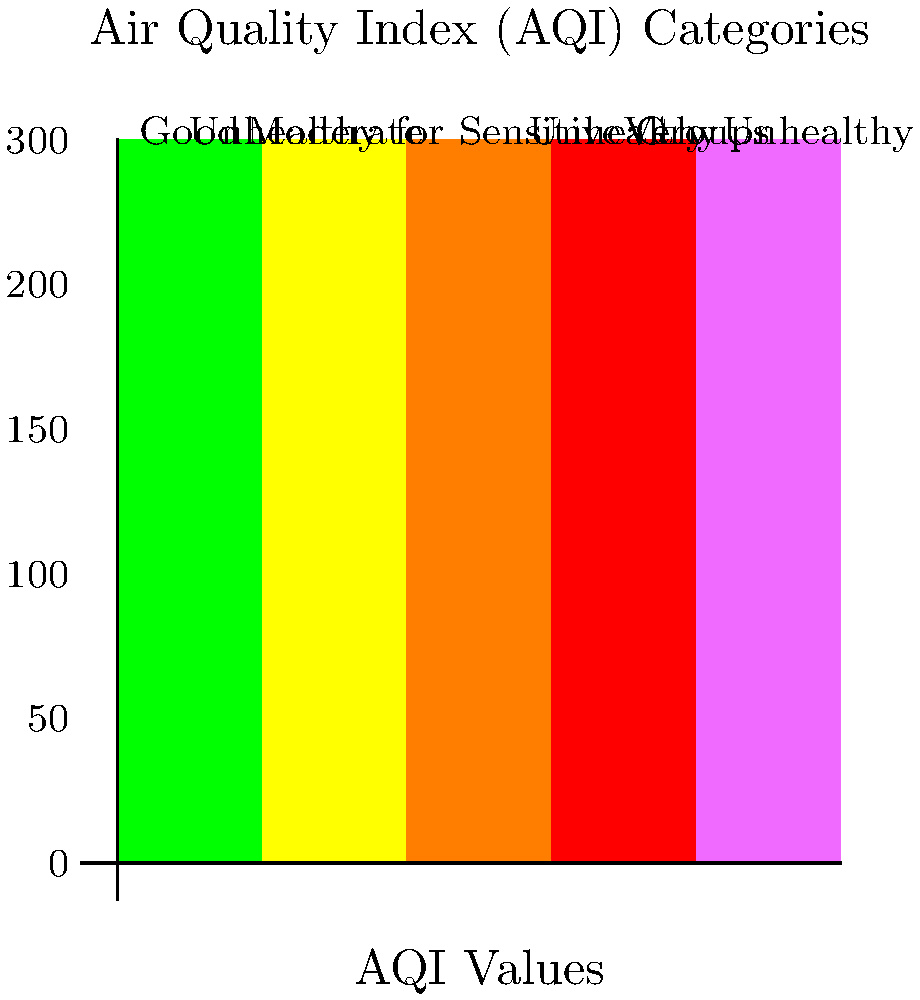Based on the color-coded Air Quality Index (AQI) map provided, what would be the appropriate health advisory for the general public if a city's AQI value is reported as 175? To determine the appropriate health advisory for an AQI value of 175, we need to follow these steps:

1. Locate the AQI value of 175 on the vertical axis of the chart.
2. Identify the corresponding color category for this value.
3. Interpret the meaning of this category in terms of health effects.

Step 1: An AQI value of 175 falls between 150 and 200 on the vertical axis.

Step 2: The color corresponding to this range is red.

Step 3: The red category is labeled "Unhealthy" in the AQI Categories.

Interpretation:
When the AQI is in the "Unhealthy" range (151-200):
- Everyone may begin to experience some adverse health effects.
- Members of sensitive groups (e.g., people with lung disease, older adults, and children) may experience more serious health effects.

The appropriate health advisory for the general public would be:
- Reduce prolonged or heavy exertion outdoors.
- Consider moving activities indoors or rescheduling to times when air quality is better.
- People with respiratory or heart conditions, the elderly, and children should avoid prolonged outdoor exposure.
- If possible, stay indoors and keep windows closed.
- Use air purifiers if available.
- Monitor symptoms and seek medical attention if experiencing difficulty breathing, chest pain, or other severe symptoms.
Answer: Reduce outdoor activities; sensitive groups should avoid prolonged exposure. 